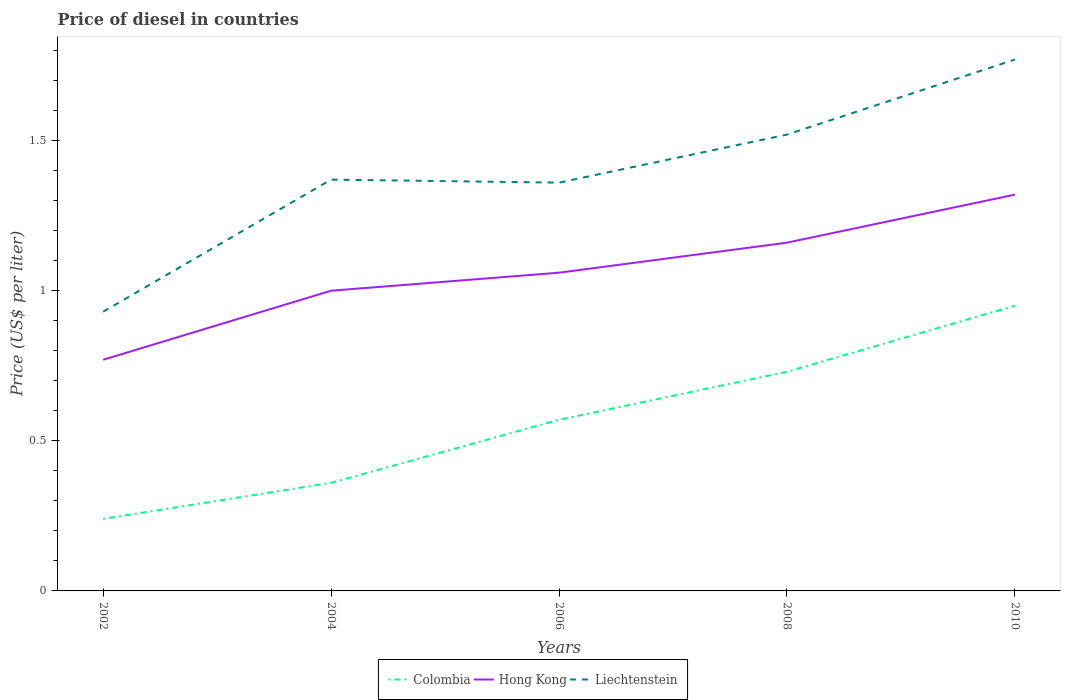Does the line corresponding to Liechtenstein intersect with the line corresponding to Colombia?
Make the answer very short. No. Across all years, what is the maximum price of diesel in Liechtenstein?
Your answer should be very brief. 0.93. In which year was the price of diesel in Hong Kong maximum?
Offer a terse response. 2002. What is the total price of diesel in Colombia in the graph?
Make the answer very short. -0.33. What is the difference between the highest and the second highest price of diesel in Hong Kong?
Offer a terse response. 0.55. What is the difference between the highest and the lowest price of diesel in Hong Kong?
Provide a short and direct response. 2. What is the difference between two consecutive major ticks on the Y-axis?
Your answer should be compact. 0.5. Are the values on the major ticks of Y-axis written in scientific E-notation?
Your response must be concise. No. Does the graph contain any zero values?
Offer a terse response. No. Does the graph contain grids?
Your answer should be compact. No. Where does the legend appear in the graph?
Provide a short and direct response. Bottom center. How many legend labels are there?
Provide a short and direct response. 3. What is the title of the graph?
Your response must be concise. Price of diesel in countries. What is the label or title of the Y-axis?
Your answer should be compact. Price (US$ per liter). What is the Price (US$ per liter) of Colombia in 2002?
Offer a terse response. 0.24. What is the Price (US$ per liter) of Hong Kong in 2002?
Offer a terse response. 0.77. What is the Price (US$ per liter) of Colombia in 2004?
Provide a short and direct response. 0.36. What is the Price (US$ per liter) in Hong Kong in 2004?
Your answer should be very brief. 1. What is the Price (US$ per liter) of Liechtenstein in 2004?
Your response must be concise. 1.37. What is the Price (US$ per liter) of Colombia in 2006?
Your answer should be very brief. 0.57. What is the Price (US$ per liter) of Hong Kong in 2006?
Offer a very short reply. 1.06. What is the Price (US$ per liter) in Liechtenstein in 2006?
Your answer should be compact. 1.36. What is the Price (US$ per liter) in Colombia in 2008?
Ensure brevity in your answer.  0.73. What is the Price (US$ per liter) of Hong Kong in 2008?
Provide a succinct answer. 1.16. What is the Price (US$ per liter) in Liechtenstein in 2008?
Offer a terse response. 1.52. What is the Price (US$ per liter) in Colombia in 2010?
Ensure brevity in your answer.  0.95. What is the Price (US$ per liter) of Hong Kong in 2010?
Your answer should be very brief. 1.32. What is the Price (US$ per liter) of Liechtenstein in 2010?
Keep it short and to the point. 1.77. Across all years, what is the maximum Price (US$ per liter) of Hong Kong?
Give a very brief answer. 1.32. Across all years, what is the maximum Price (US$ per liter) of Liechtenstein?
Make the answer very short. 1.77. Across all years, what is the minimum Price (US$ per liter) in Colombia?
Provide a succinct answer. 0.24. Across all years, what is the minimum Price (US$ per liter) of Hong Kong?
Offer a very short reply. 0.77. What is the total Price (US$ per liter) in Colombia in the graph?
Provide a short and direct response. 2.85. What is the total Price (US$ per liter) of Hong Kong in the graph?
Your answer should be compact. 5.31. What is the total Price (US$ per liter) in Liechtenstein in the graph?
Your response must be concise. 6.95. What is the difference between the Price (US$ per liter) in Colombia in 2002 and that in 2004?
Provide a short and direct response. -0.12. What is the difference between the Price (US$ per liter) in Hong Kong in 2002 and that in 2004?
Your answer should be compact. -0.23. What is the difference between the Price (US$ per liter) in Liechtenstein in 2002 and that in 2004?
Offer a very short reply. -0.44. What is the difference between the Price (US$ per liter) in Colombia in 2002 and that in 2006?
Your answer should be very brief. -0.33. What is the difference between the Price (US$ per liter) of Hong Kong in 2002 and that in 2006?
Make the answer very short. -0.29. What is the difference between the Price (US$ per liter) in Liechtenstein in 2002 and that in 2006?
Ensure brevity in your answer.  -0.43. What is the difference between the Price (US$ per liter) in Colombia in 2002 and that in 2008?
Your response must be concise. -0.49. What is the difference between the Price (US$ per liter) of Hong Kong in 2002 and that in 2008?
Provide a short and direct response. -0.39. What is the difference between the Price (US$ per liter) in Liechtenstein in 2002 and that in 2008?
Your answer should be very brief. -0.59. What is the difference between the Price (US$ per liter) in Colombia in 2002 and that in 2010?
Your response must be concise. -0.71. What is the difference between the Price (US$ per liter) in Hong Kong in 2002 and that in 2010?
Your answer should be very brief. -0.55. What is the difference between the Price (US$ per liter) of Liechtenstein in 2002 and that in 2010?
Ensure brevity in your answer.  -0.84. What is the difference between the Price (US$ per liter) in Colombia in 2004 and that in 2006?
Offer a terse response. -0.21. What is the difference between the Price (US$ per liter) in Hong Kong in 2004 and that in 2006?
Make the answer very short. -0.06. What is the difference between the Price (US$ per liter) of Colombia in 2004 and that in 2008?
Make the answer very short. -0.37. What is the difference between the Price (US$ per liter) in Hong Kong in 2004 and that in 2008?
Your answer should be compact. -0.16. What is the difference between the Price (US$ per liter) in Colombia in 2004 and that in 2010?
Offer a terse response. -0.59. What is the difference between the Price (US$ per liter) in Hong Kong in 2004 and that in 2010?
Provide a succinct answer. -0.32. What is the difference between the Price (US$ per liter) in Liechtenstein in 2004 and that in 2010?
Keep it short and to the point. -0.4. What is the difference between the Price (US$ per liter) of Colombia in 2006 and that in 2008?
Provide a succinct answer. -0.16. What is the difference between the Price (US$ per liter) of Hong Kong in 2006 and that in 2008?
Offer a terse response. -0.1. What is the difference between the Price (US$ per liter) in Liechtenstein in 2006 and that in 2008?
Offer a terse response. -0.16. What is the difference between the Price (US$ per liter) in Colombia in 2006 and that in 2010?
Give a very brief answer. -0.38. What is the difference between the Price (US$ per liter) of Hong Kong in 2006 and that in 2010?
Ensure brevity in your answer.  -0.26. What is the difference between the Price (US$ per liter) of Liechtenstein in 2006 and that in 2010?
Provide a succinct answer. -0.41. What is the difference between the Price (US$ per liter) of Colombia in 2008 and that in 2010?
Your answer should be compact. -0.22. What is the difference between the Price (US$ per liter) of Hong Kong in 2008 and that in 2010?
Give a very brief answer. -0.16. What is the difference between the Price (US$ per liter) of Liechtenstein in 2008 and that in 2010?
Provide a succinct answer. -0.25. What is the difference between the Price (US$ per liter) of Colombia in 2002 and the Price (US$ per liter) of Hong Kong in 2004?
Provide a short and direct response. -0.76. What is the difference between the Price (US$ per liter) in Colombia in 2002 and the Price (US$ per liter) in Liechtenstein in 2004?
Your response must be concise. -1.13. What is the difference between the Price (US$ per liter) of Hong Kong in 2002 and the Price (US$ per liter) of Liechtenstein in 2004?
Offer a very short reply. -0.6. What is the difference between the Price (US$ per liter) of Colombia in 2002 and the Price (US$ per liter) of Hong Kong in 2006?
Give a very brief answer. -0.82. What is the difference between the Price (US$ per liter) of Colombia in 2002 and the Price (US$ per liter) of Liechtenstein in 2006?
Ensure brevity in your answer.  -1.12. What is the difference between the Price (US$ per liter) in Hong Kong in 2002 and the Price (US$ per liter) in Liechtenstein in 2006?
Offer a terse response. -0.59. What is the difference between the Price (US$ per liter) in Colombia in 2002 and the Price (US$ per liter) in Hong Kong in 2008?
Your answer should be very brief. -0.92. What is the difference between the Price (US$ per liter) of Colombia in 2002 and the Price (US$ per liter) of Liechtenstein in 2008?
Give a very brief answer. -1.28. What is the difference between the Price (US$ per liter) in Hong Kong in 2002 and the Price (US$ per liter) in Liechtenstein in 2008?
Provide a short and direct response. -0.75. What is the difference between the Price (US$ per liter) in Colombia in 2002 and the Price (US$ per liter) in Hong Kong in 2010?
Offer a very short reply. -1.08. What is the difference between the Price (US$ per liter) of Colombia in 2002 and the Price (US$ per liter) of Liechtenstein in 2010?
Your answer should be compact. -1.53. What is the difference between the Price (US$ per liter) in Hong Kong in 2002 and the Price (US$ per liter) in Liechtenstein in 2010?
Give a very brief answer. -1. What is the difference between the Price (US$ per liter) in Colombia in 2004 and the Price (US$ per liter) in Liechtenstein in 2006?
Provide a short and direct response. -1. What is the difference between the Price (US$ per liter) of Hong Kong in 2004 and the Price (US$ per liter) of Liechtenstein in 2006?
Give a very brief answer. -0.36. What is the difference between the Price (US$ per liter) in Colombia in 2004 and the Price (US$ per liter) in Hong Kong in 2008?
Your answer should be very brief. -0.8. What is the difference between the Price (US$ per liter) of Colombia in 2004 and the Price (US$ per liter) of Liechtenstein in 2008?
Offer a very short reply. -1.16. What is the difference between the Price (US$ per liter) in Hong Kong in 2004 and the Price (US$ per liter) in Liechtenstein in 2008?
Your answer should be compact. -0.52. What is the difference between the Price (US$ per liter) of Colombia in 2004 and the Price (US$ per liter) of Hong Kong in 2010?
Provide a succinct answer. -0.96. What is the difference between the Price (US$ per liter) in Colombia in 2004 and the Price (US$ per liter) in Liechtenstein in 2010?
Make the answer very short. -1.41. What is the difference between the Price (US$ per liter) of Hong Kong in 2004 and the Price (US$ per liter) of Liechtenstein in 2010?
Your answer should be very brief. -0.77. What is the difference between the Price (US$ per liter) in Colombia in 2006 and the Price (US$ per liter) in Hong Kong in 2008?
Offer a terse response. -0.59. What is the difference between the Price (US$ per liter) in Colombia in 2006 and the Price (US$ per liter) in Liechtenstein in 2008?
Make the answer very short. -0.95. What is the difference between the Price (US$ per liter) of Hong Kong in 2006 and the Price (US$ per liter) of Liechtenstein in 2008?
Your answer should be very brief. -0.46. What is the difference between the Price (US$ per liter) in Colombia in 2006 and the Price (US$ per liter) in Hong Kong in 2010?
Give a very brief answer. -0.75. What is the difference between the Price (US$ per liter) of Colombia in 2006 and the Price (US$ per liter) of Liechtenstein in 2010?
Offer a very short reply. -1.2. What is the difference between the Price (US$ per liter) in Hong Kong in 2006 and the Price (US$ per liter) in Liechtenstein in 2010?
Give a very brief answer. -0.71. What is the difference between the Price (US$ per liter) in Colombia in 2008 and the Price (US$ per liter) in Hong Kong in 2010?
Give a very brief answer. -0.59. What is the difference between the Price (US$ per liter) of Colombia in 2008 and the Price (US$ per liter) of Liechtenstein in 2010?
Make the answer very short. -1.04. What is the difference between the Price (US$ per liter) of Hong Kong in 2008 and the Price (US$ per liter) of Liechtenstein in 2010?
Your response must be concise. -0.61. What is the average Price (US$ per liter) in Colombia per year?
Keep it short and to the point. 0.57. What is the average Price (US$ per liter) of Hong Kong per year?
Provide a short and direct response. 1.06. What is the average Price (US$ per liter) in Liechtenstein per year?
Offer a terse response. 1.39. In the year 2002, what is the difference between the Price (US$ per liter) of Colombia and Price (US$ per liter) of Hong Kong?
Your response must be concise. -0.53. In the year 2002, what is the difference between the Price (US$ per liter) of Colombia and Price (US$ per liter) of Liechtenstein?
Offer a terse response. -0.69. In the year 2002, what is the difference between the Price (US$ per liter) of Hong Kong and Price (US$ per liter) of Liechtenstein?
Your answer should be compact. -0.16. In the year 2004, what is the difference between the Price (US$ per liter) of Colombia and Price (US$ per liter) of Hong Kong?
Ensure brevity in your answer.  -0.64. In the year 2004, what is the difference between the Price (US$ per liter) of Colombia and Price (US$ per liter) of Liechtenstein?
Give a very brief answer. -1.01. In the year 2004, what is the difference between the Price (US$ per liter) of Hong Kong and Price (US$ per liter) of Liechtenstein?
Make the answer very short. -0.37. In the year 2006, what is the difference between the Price (US$ per liter) in Colombia and Price (US$ per liter) in Hong Kong?
Offer a terse response. -0.49. In the year 2006, what is the difference between the Price (US$ per liter) in Colombia and Price (US$ per liter) in Liechtenstein?
Make the answer very short. -0.79. In the year 2008, what is the difference between the Price (US$ per liter) in Colombia and Price (US$ per liter) in Hong Kong?
Offer a very short reply. -0.43. In the year 2008, what is the difference between the Price (US$ per liter) of Colombia and Price (US$ per liter) of Liechtenstein?
Your answer should be very brief. -0.79. In the year 2008, what is the difference between the Price (US$ per liter) of Hong Kong and Price (US$ per liter) of Liechtenstein?
Make the answer very short. -0.36. In the year 2010, what is the difference between the Price (US$ per liter) in Colombia and Price (US$ per liter) in Hong Kong?
Make the answer very short. -0.37. In the year 2010, what is the difference between the Price (US$ per liter) in Colombia and Price (US$ per liter) in Liechtenstein?
Your response must be concise. -0.82. In the year 2010, what is the difference between the Price (US$ per liter) in Hong Kong and Price (US$ per liter) in Liechtenstein?
Ensure brevity in your answer.  -0.45. What is the ratio of the Price (US$ per liter) in Hong Kong in 2002 to that in 2004?
Keep it short and to the point. 0.77. What is the ratio of the Price (US$ per liter) of Liechtenstein in 2002 to that in 2004?
Your answer should be very brief. 0.68. What is the ratio of the Price (US$ per liter) of Colombia in 2002 to that in 2006?
Give a very brief answer. 0.42. What is the ratio of the Price (US$ per liter) of Hong Kong in 2002 to that in 2006?
Give a very brief answer. 0.73. What is the ratio of the Price (US$ per liter) of Liechtenstein in 2002 to that in 2006?
Ensure brevity in your answer.  0.68. What is the ratio of the Price (US$ per liter) of Colombia in 2002 to that in 2008?
Offer a very short reply. 0.33. What is the ratio of the Price (US$ per liter) in Hong Kong in 2002 to that in 2008?
Provide a short and direct response. 0.66. What is the ratio of the Price (US$ per liter) of Liechtenstein in 2002 to that in 2008?
Provide a succinct answer. 0.61. What is the ratio of the Price (US$ per liter) in Colombia in 2002 to that in 2010?
Make the answer very short. 0.25. What is the ratio of the Price (US$ per liter) of Hong Kong in 2002 to that in 2010?
Give a very brief answer. 0.58. What is the ratio of the Price (US$ per liter) in Liechtenstein in 2002 to that in 2010?
Your response must be concise. 0.53. What is the ratio of the Price (US$ per liter) in Colombia in 2004 to that in 2006?
Provide a short and direct response. 0.63. What is the ratio of the Price (US$ per liter) of Hong Kong in 2004 to that in 2006?
Ensure brevity in your answer.  0.94. What is the ratio of the Price (US$ per liter) in Liechtenstein in 2004 to that in 2006?
Your answer should be compact. 1.01. What is the ratio of the Price (US$ per liter) in Colombia in 2004 to that in 2008?
Offer a terse response. 0.49. What is the ratio of the Price (US$ per liter) in Hong Kong in 2004 to that in 2008?
Provide a short and direct response. 0.86. What is the ratio of the Price (US$ per liter) of Liechtenstein in 2004 to that in 2008?
Provide a succinct answer. 0.9. What is the ratio of the Price (US$ per liter) in Colombia in 2004 to that in 2010?
Provide a short and direct response. 0.38. What is the ratio of the Price (US$ per liter) of Hong Kong in 2004 to that in 2010?
Keep it short and to the point. 0.76. What is the ratio of the Price (US$ per liter) of Liechtenstein in 2004 to that in 2010?
Your answer should be compact. 0.77. What is the ratio of the Price (US$ per liter) in Colombia in 2006 to that in 2008?
Give a very brief answer. 0.78. What is the ratio of the Price (US$ per liter) in Hong Kong in 2006 to that in 2008?
Your response must be concise. 0.91. What is the ratio of the Price (US$ per liter) of Liechtenstein in 2006 to that in 2008?
Your answer should be very brief. 0.89. What is the ratio of the Price (US$ per liter) in Hong Kong in 2006 to that in 2010?
Your answer should be compact. 0.8. What is the ratio of the Price (US$ per liter) in Liechtenstein in 2006 to that in 2010?
Provide a short and direct response. 0.77. What is the ratio of the Price (US$ per liter) of Colombia in 2008 to that in 2010?
Provide a short and direct response. 0.77. What is the ratio of the Price (US$ per liter) of Hong Kong in 2008 to that in 2010?
Your response must be concise. 0.88. What is the ratio of the Price (US$ per liter) of Liechtenstein in 2008 to that in 2010?
Offer a terse response. 0.86. What is the difference between the highest and the second highest Price (US$ per liter) in Colombia?
Give a very brief answer. 0.22. What is the difference between the highest and the second highest Price (US$ per liter) in Hong Kong?
Offer a terse response. 0.16. What is the difference between the highest and the lowest Price (US$ per liter) of Colombia?
Your response must be concise. 0.71. What is the difference between the highest and the lowest Price (US$ per liter) of Hong Kong?
Provide a succinct answer. 0.55. What is the difference between the highest and the lowest Price (US$ per liter) of Liechtenstein?
Keep it short and to the point. 0.84. 